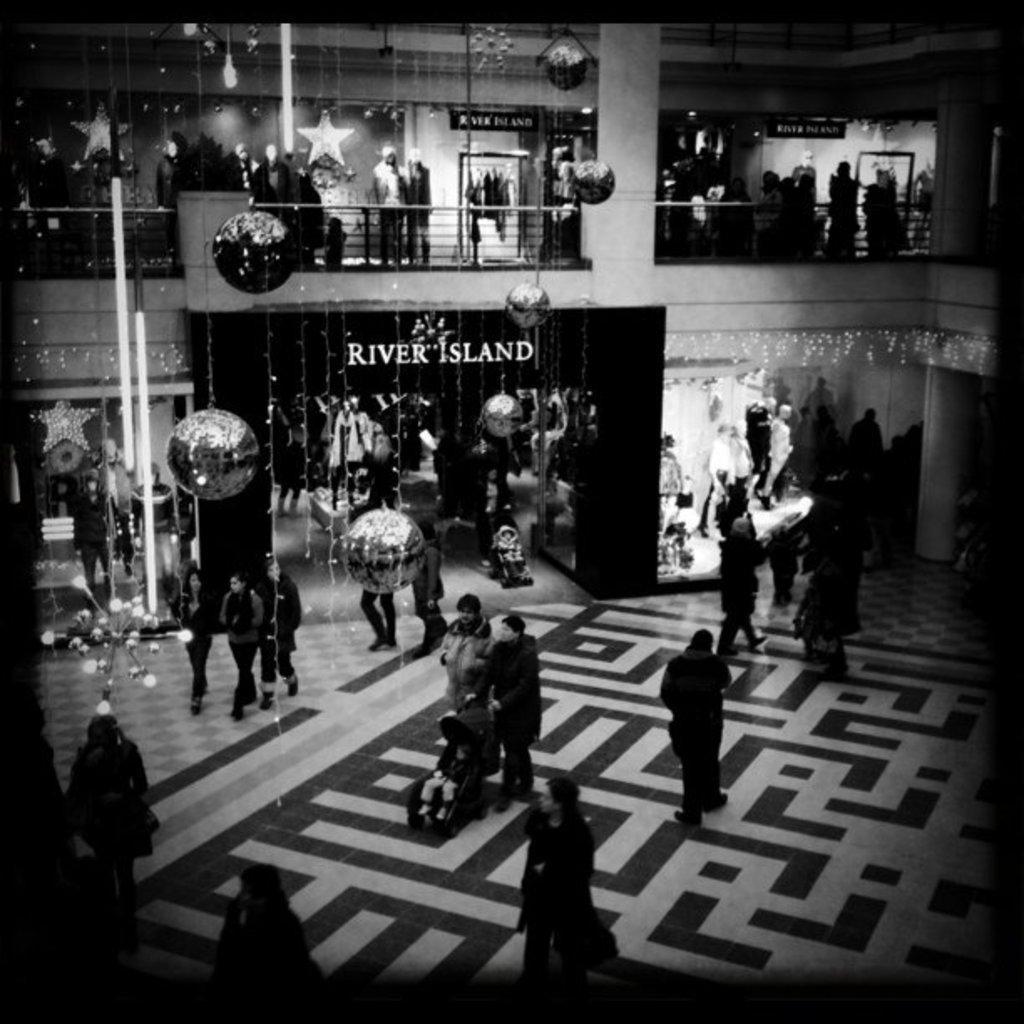Could you give a brief overview of what you see in this image? In this image we can see the inside view of a mall which is decorated with balloons, stars and some other lights, there are some group of persons walking through the floor and in the background of the image there are some stores. 